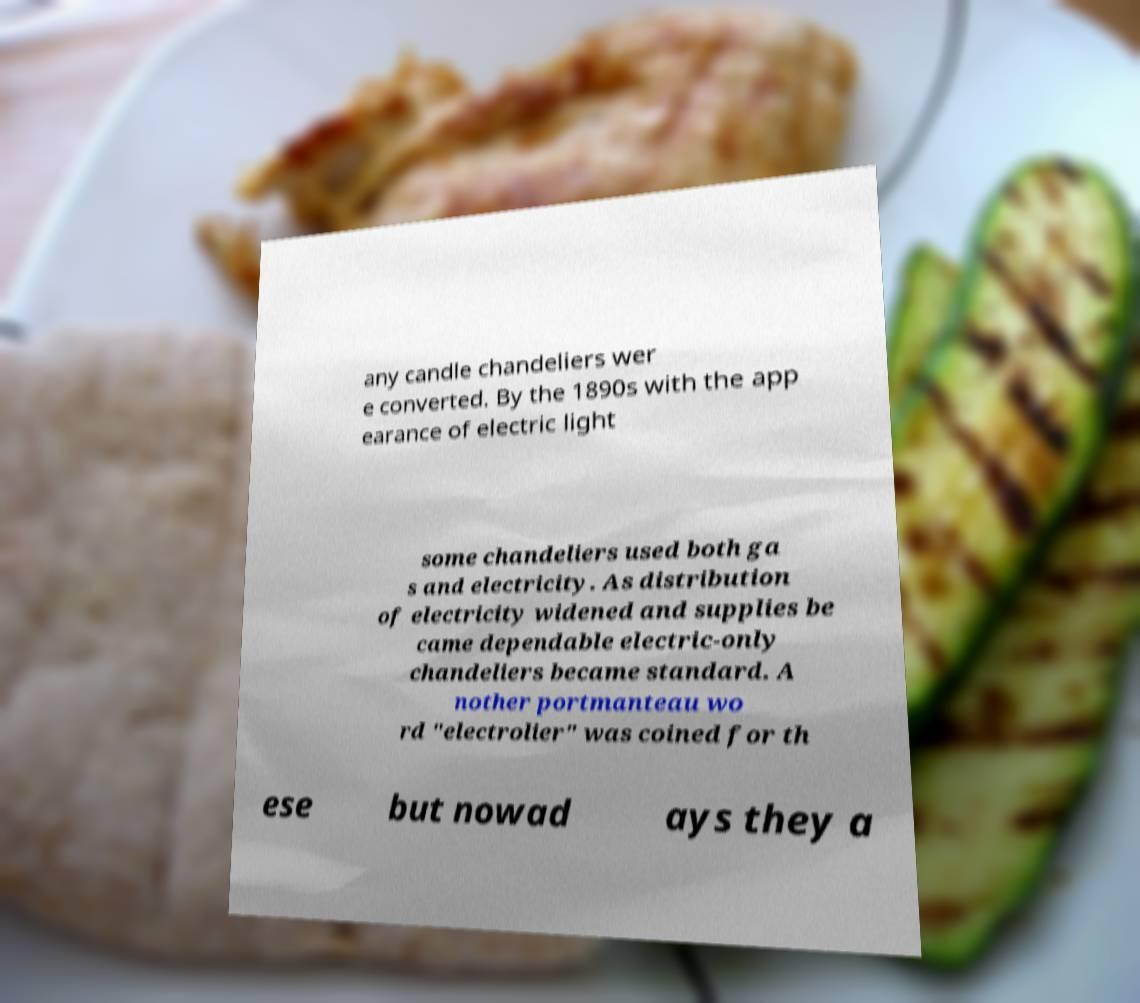Please identify and transcribe the text found in this image. any candle chandeliers wer e converted. By the 1890s with the app earance of electric light some chandeliers used both ga s and electricity. As distribution of electricity widened and supplies be came dependable electric-only chandeliers became standard. A nother portmanteau wo rd "electrolier" was coined for th ese but nowad ays they a 